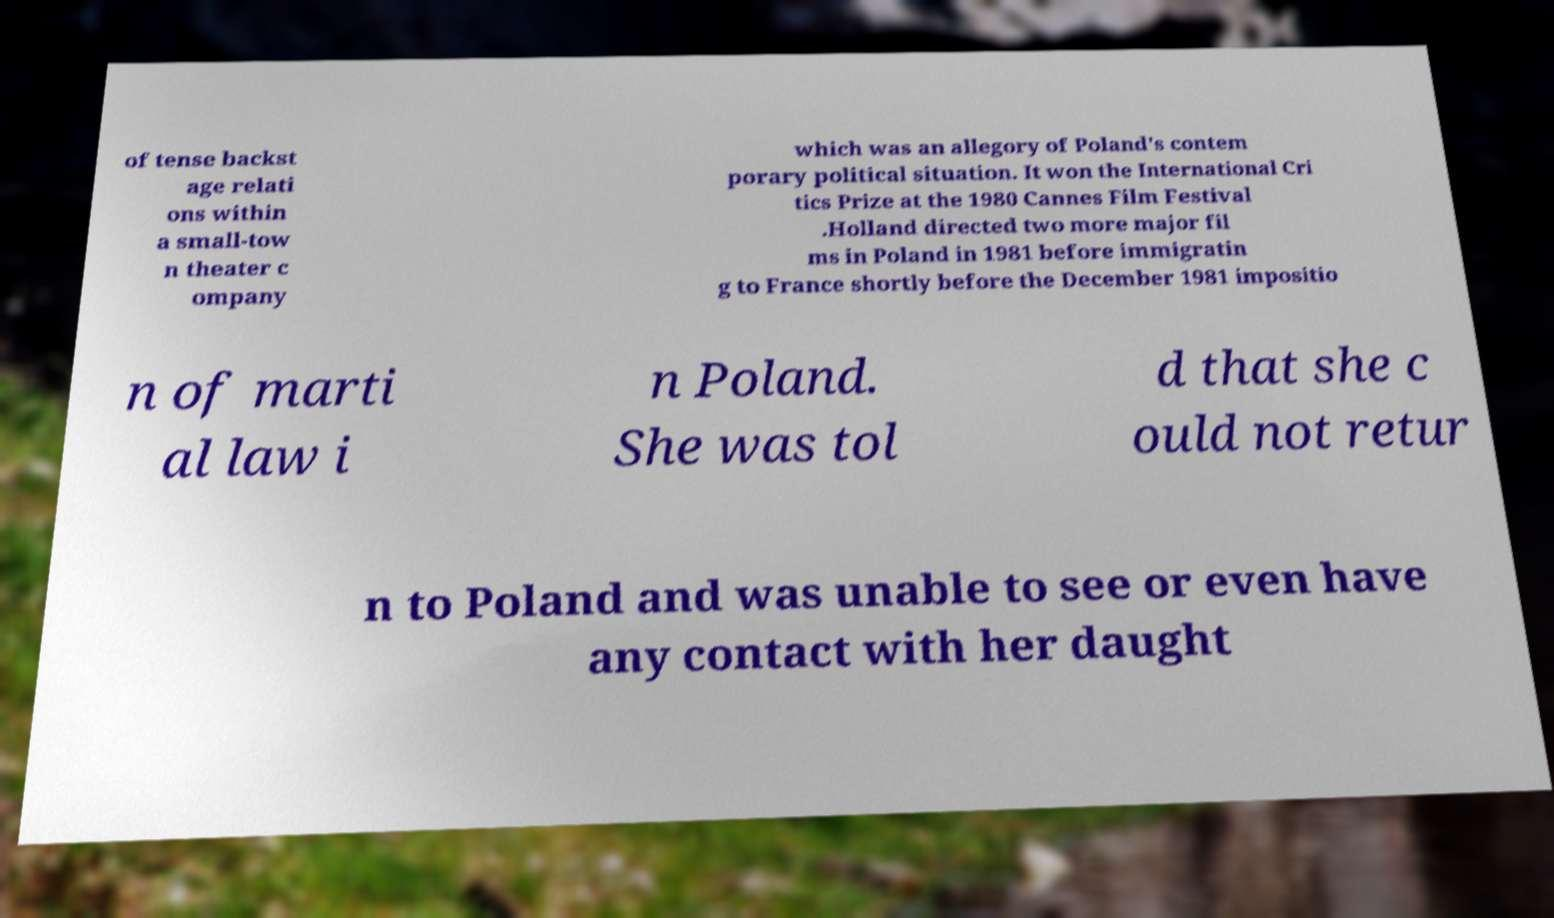Can you accurately transcribe the text from the provided image for me? of tense backst age relati ons within a small-tow n theater c ompany which was an allegory of Poland's contem porary political situation. It won the International Cri tics Prize at the 1980 Cannes Film Festival .Holland directed two more major fil ms in Poland in 1981 before immigratin g to France shortly before the December 1981 impositio n of marti al law i n Poland. She was tol d that she c ould not retur n to Poland and was unable to see or even have any contact with her daught 